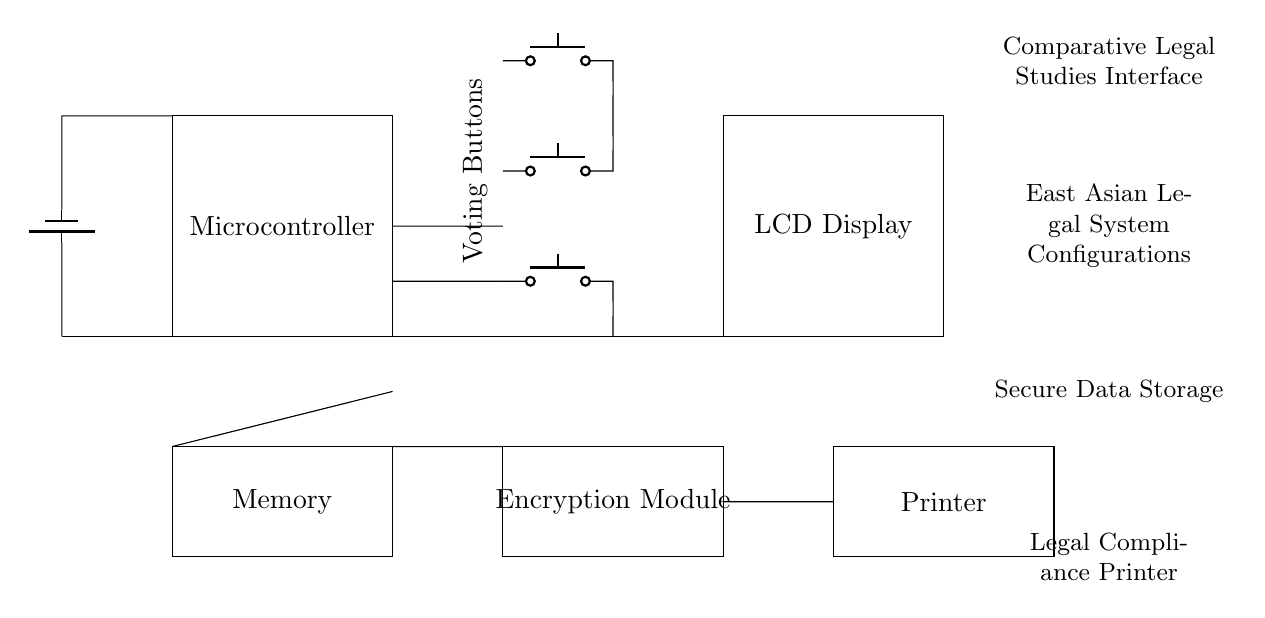What is the main power supply component? The main power supply component is a battery, which is represented in the circuit. It provides the necessary voltage for the entire circuit.
Answer: Battery How many voting buttons are there? There are three voting buttons indicated in the circuit. The buttons are arranged vertically, clearly separated in the diagram.
Answer: Three What does the microcontroller do in this circuit? The microcontroller processes the input from the voting buttons and manages the communication between the voting interface, memory, and display. Its functionality is central to the operation of the device.
Answer: Control processing What type of display is used? The circuit features an LCD display, which is specified to present information and results in an electronic voting machine context.
Answer: LCD Display What is the purpose of the encryption module? The encryption module secures data by encoding the voting information, ensuring confidentiality and protection against tampering. As shown, it is positioned adjacent to other components handling sensitive data.
Answer: Data security How is data stored in the circuit? Data is stored in a memory component, which is crucial for retaining voting information and other necessary data during and after the voting process. Its placement indicates its role in conjunction with other components like the microcontroller.
Answer: Memory storage What is the function of the printer in this circuit? The printer outputs the legal compliance document, producing a physical record of the voting outcomes, which is essential for transparency and verification in the electoral process.
Answer: Legal compliance printer 